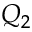<formula> <loc_0><loc_0><loc_500><loc_500>Q _ { 2 }</formula> 